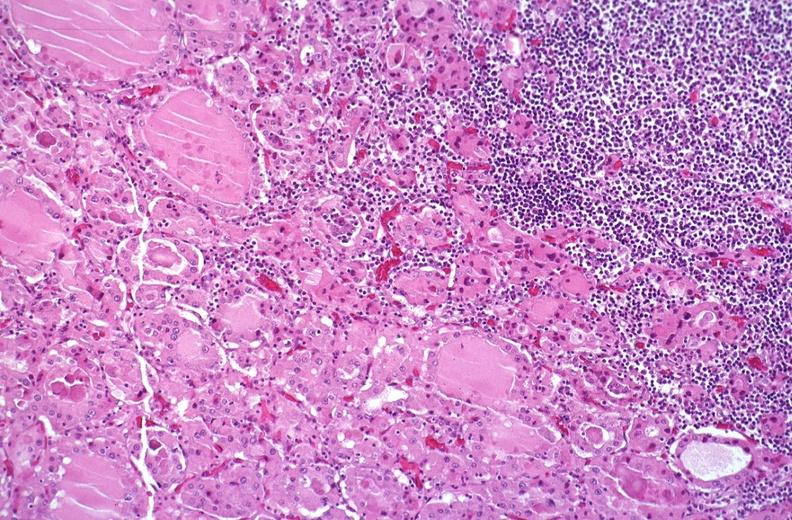does adrenal show hashimoto 's thyroiditis?
Answer the question using a single word or phrase. No 